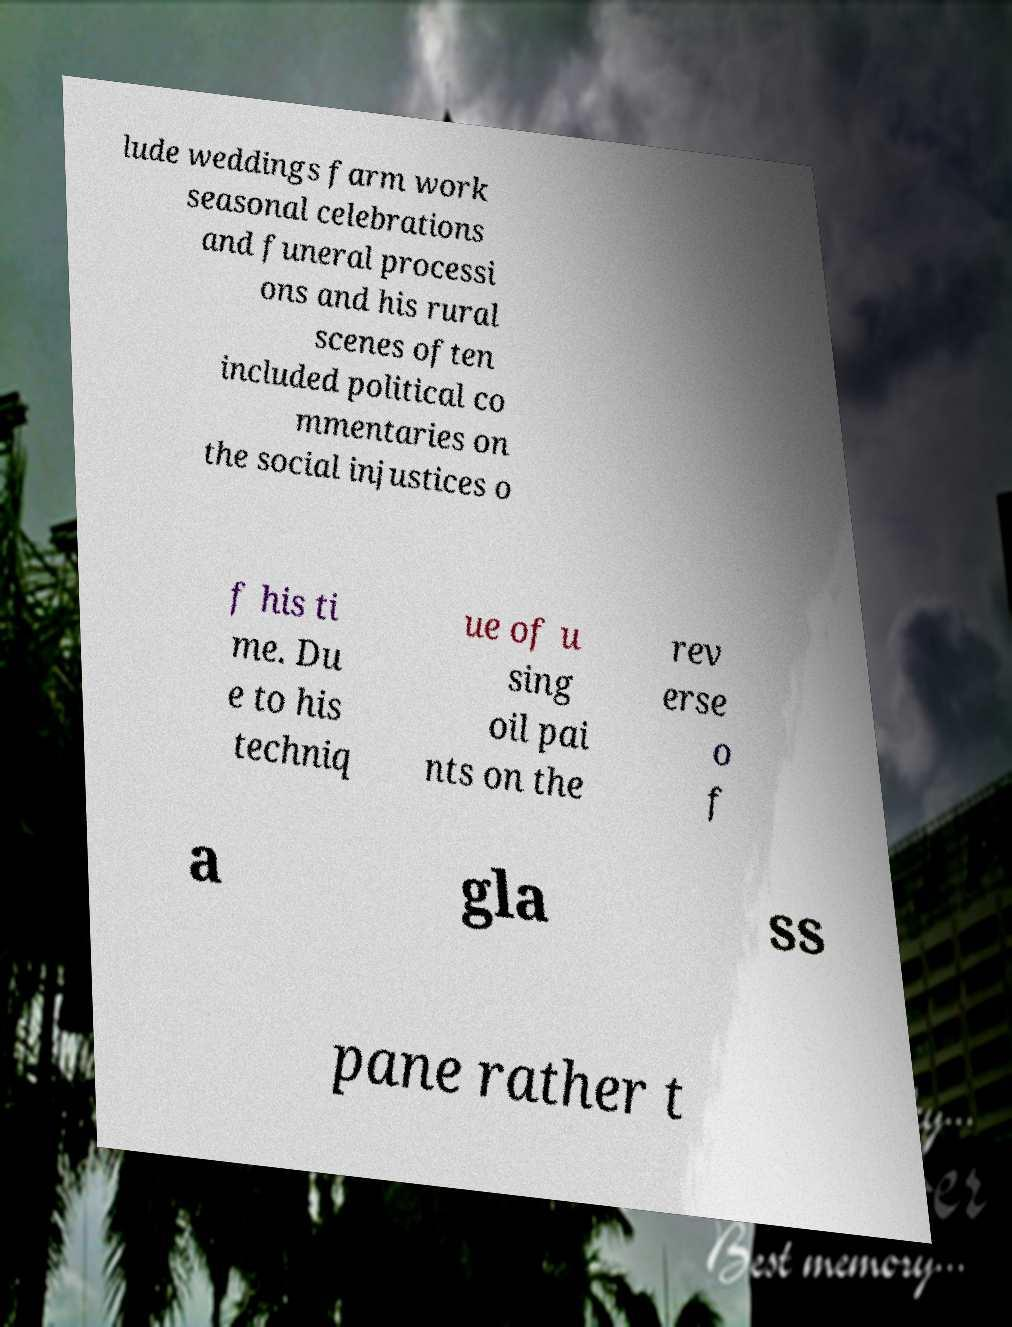There's text embedded in this image that I need extracted. Can you transcribe it verbatim? lude weddings farm work seasonal celebrations and funeral processi ons and his rural scenes often included political co mmentaries on the social injustices o f his ti me. Du e to his techniq ue of u sing oil pai nts on the rev erse o f a gla ss pane rather t 